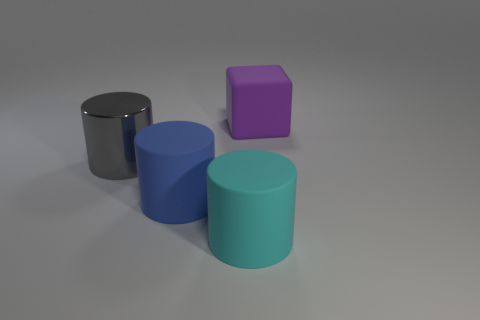Add 1 large gray objects. How many objects exist? 5 Subtract all yellow cylinders. Subtract all red cubes. How many cylinders are left? 3 Subtract all cylinders. How many objects are left? 1 Subtract 0 blue blocks. How many objects are left? 4 Subtract all blue cylinders. Subtract all large rubber objects. How many objects are left? 0 Add 3 gray things. How many gray things are left? 4 Add 4 big yellow metal blocks. How many big yellow metal blocks exist? 4 